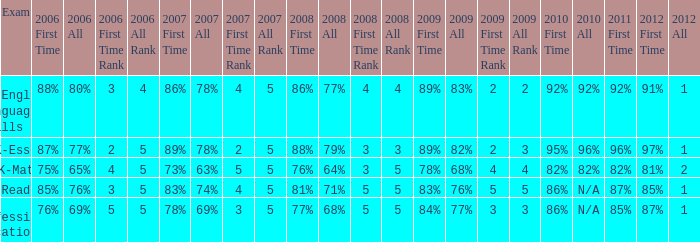What is the percentage for first time 2011 when the first time in 2009 is 68%? 82%. 